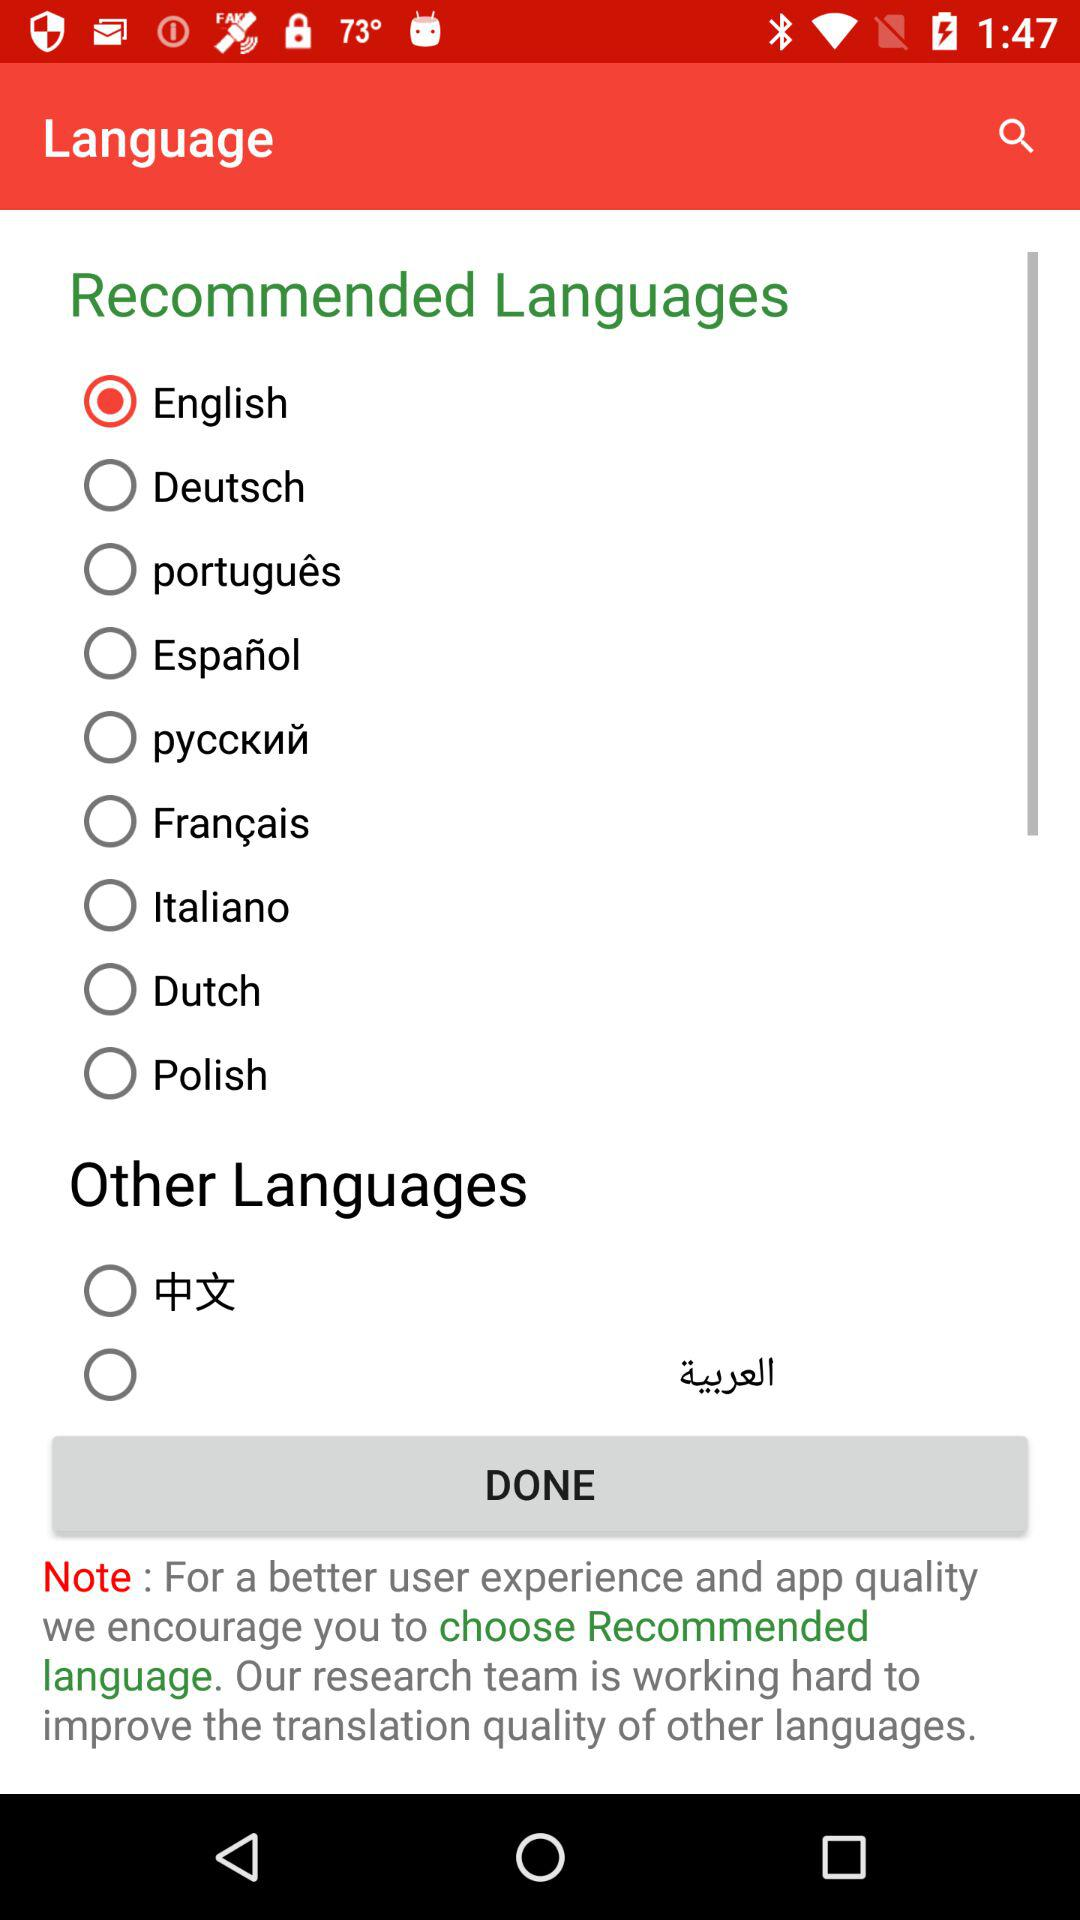What are the options available in "Recommended Languages"? The available options are "English", "Deutsch", "português", "Español", "pyccкий", "Français", "Italiano", "Dutch", and "Polish". 